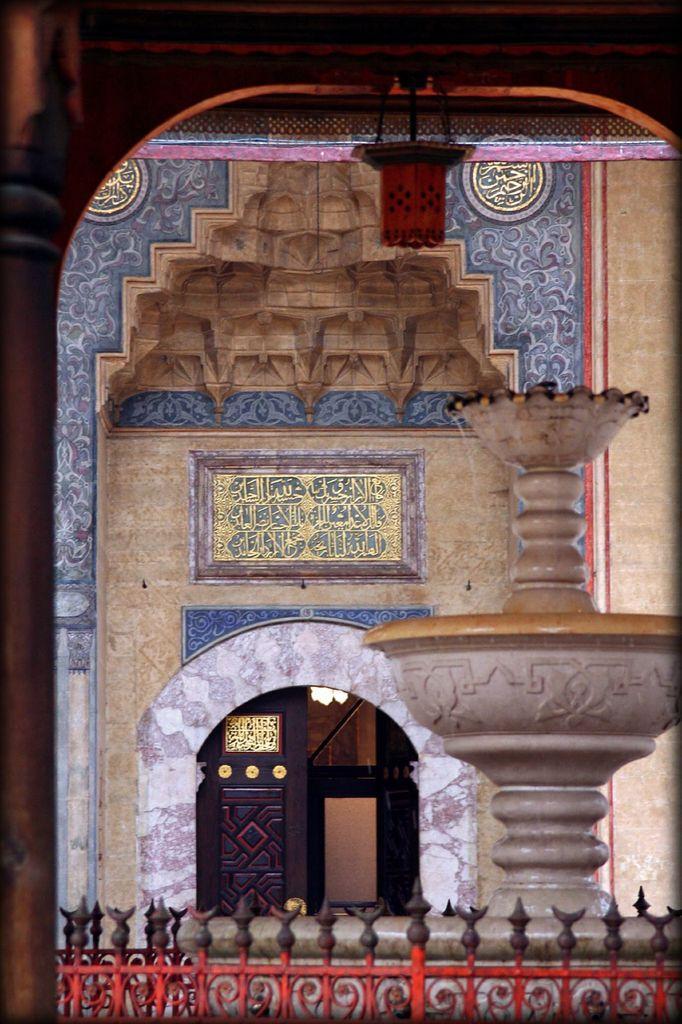Can you describe this image briefly? In this image there is a wall of the house. There is a board with text on the wall of the house. In front of the house there is a water fountain. At the bottom there is a railing. There is a wooden door to the wall. In the foreground there is n arch. At the top there is a lantern to the ceiling. 